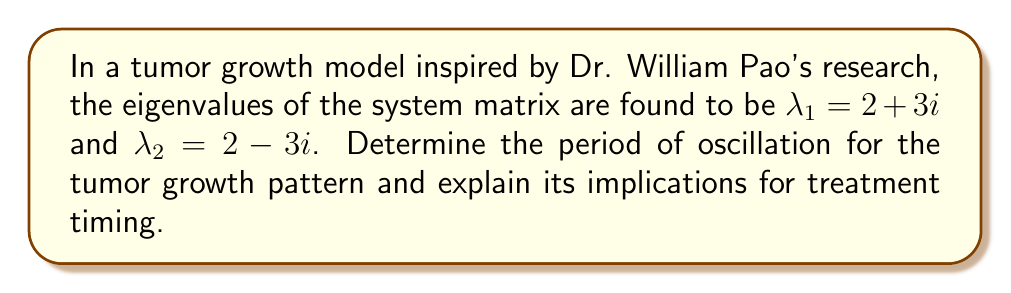Can you solve this math problem? Let's approach this step-by-step:

1) The complex eigenvalues are in the form $a \pm bi$, where:
   $a = 2$ (real part)
   $b = 3$ (imaginary part)

2) For complex eigenvalues, the general solution has the form:
   $$x(t) = e^{at}(c_1 \cos(bt) + c_2 \sin(bt))$$

3) The period of oscillation is determined by the imaginary part of the eigenvalues:
   $$T = \frac{2\pi}{|b|}$$

4) Substituting $b = 3$:
   $$T = \frac{2\pi}{|3|} = \frac{2\pi}{3}$$

5) To convert to a more practical unit, let's assume time is measured in days:
   $$T \approx 2.0944 \text{ days}$$

6) Implications for treatment:
   - The tumor growth pattern oscillates approximately every 2.09 days.
   - This suggests that the tumor may be more susceptible to treatment at certain points in this cycle.
   - Treatment could potentially be timed to coincide with the most vulnerable phase of the tumor's growth cycle.
   - However, the real part of the eigenvalue ($a = 2$) being positive indicates overall exponential growth, emphasizing the need for prompt and effective treatment.
Answer: $\frac{2\pi}{3}$ days (≈ 2.09 days) 